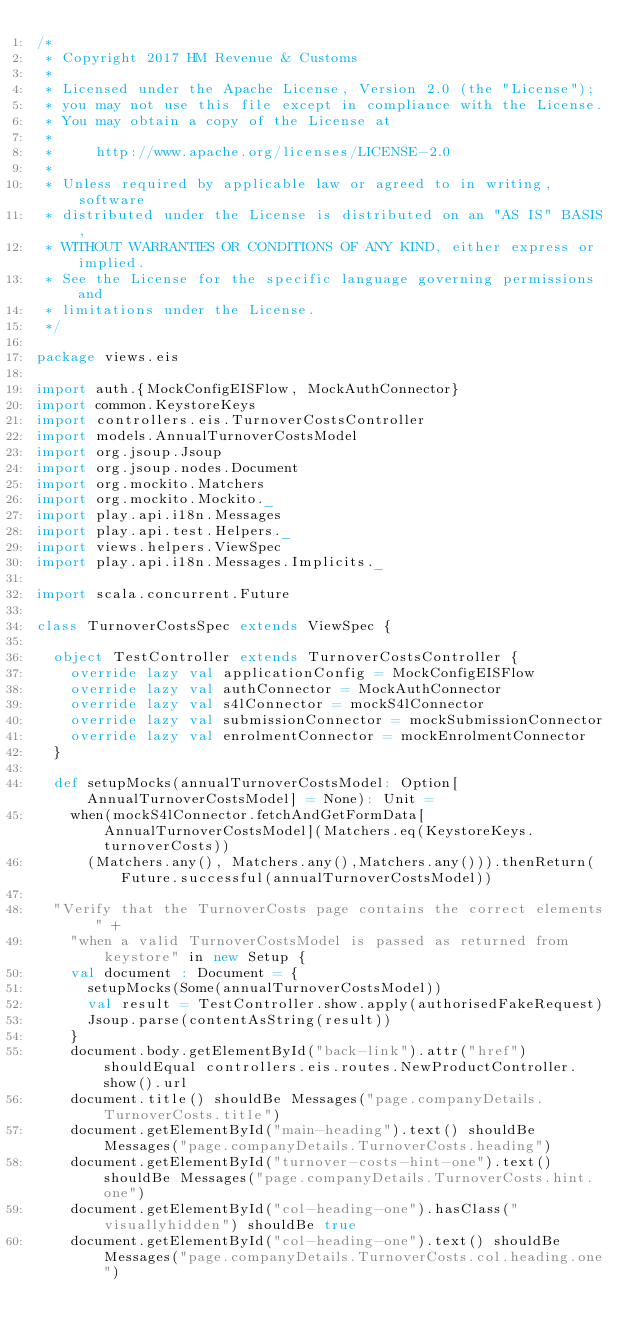Convert code to text. <code><loc_0><loc_0><loc_500><loc_500><_Scala_>/*
 * Copyright 2017 HM Revenue & Customs
 *
 * Licensed under the Apache License, Version 2.0 (the "License");
 * you may not use this file except in compliance with the License.
 * You may obtain a copy of the License at
 *
 *     http://www.apache.org/licenses/LICENSE-2.0
 *
 * Unless required by applicable law or agreed to in writing, software
 * distributed under the License is distributed on an "AS IS" BASIS,
 * WITHOUT WARRANTIES OR CONDITIONS OF ANY KIND, either express or implied.
 * See the License for the specific language governing permissions and
 * limitations under the License.
 */

package views.eis

import auth.{MockConfigEISFlow, MockAuthConnector}
import common.KeystoreKeys
import controllers.eis.TurnoverCostsController
import models.AnnualTurnoverCostsModel
import org.jsoup.Jsoup
import org.jsoup.nodes.Document
import org.mockito.Matchers
import org.mockito.Mockito._
import play.api.i18n.Messages
import play.api.test.Helpers._
import views.helpers.ViewSpec
import play.api.i18n.Messages.Implicits._

import scala.concurrent.Future

class TurnoverCostsSpec extends ViewSpec {

  object TestController extends TurnoverCostsController {
    override lazy val applicationConfig = MockConfigEISFlow
    override lazy val authConnector = MockAuthConnector
    override lazy val s4lConnector = mockS4lConnector
    override lazy val submissionConnector = mockSubmissionConnector
    override lazy val enrolmentConnector = mockEnrolmentConnector
  }

  def setupMocks(annualTurnoverCostsModel: Option[AnnualTurnoverCostsModel] = None): Unit =
    when(mockS4lConnector.fetchAndGetFormData[AnnualTurnoverCostsModel](Matchers.eq(KeystoreKeys.turnoverCosts))
      (Matchers.any(), Matchers.any(),Matchers.any())).thenReturn(Future.successful(annualTurnoverCostsModel))

  "Verify that the TurnoverCosts page contains the correct elements " +
    "when a valid TurnoverCostsModel is passed as returned from keystore" in new Setup {
    val document : Document = {
      setupMocks(Some(annualTurnoverCostsModel))
      val result = TestController.show.apply(authorisedFakeRequest)
      Jsoup.parse(contentAsString(result))
    }
    document.body.getElementById("back-link").attr("href") shouldEqual controllers.eis.routes.NewProductController.show().url
    document.title() shouldBe Messages("page.companyDetails.TurnoverCosts.title")
    document.getElementById("main-heading").text() shouldBe Messages("page.companyDetails.TurnoverCosts.heading")
    document.getElementById("turnover-costs-hint-one").text() shouldBe Messages("page.companyDetails.TurnoverCosts.hint.one")
    document.getElementById("col-heading-one").hasClass("visuallyhidden") shouldBe true
    document.getElementById("col-heading-one").text() shouldBe Messages("page.companyDetails.TurnoverCosts.col.heading.one")</code> 